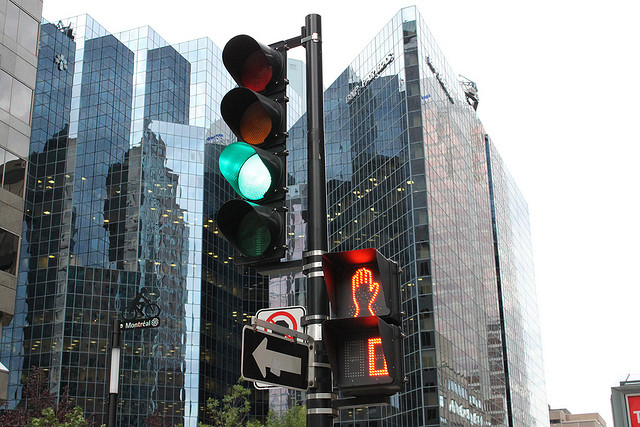Can you provide details about the weather or time of day based on the image? The image shows a clear sky with ample daylight reflecting off the building's facade, suggesting the photo was taken during the daytime under fair weather conditions. 